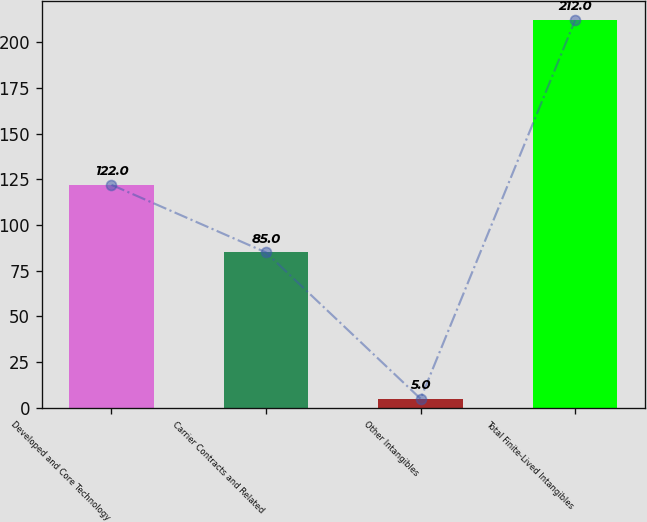Convert chart to OTSL. <chart><loc_0><loc_0><loc_500><loc_500><bar_chart><fcel>Developed and Core Technology<fcel>Carrier Contracts and Related<fcel>Other Intangibles<fcel>Total Finite-Lived Intangibles<nl><fcel>122<fcel>85<fcel>5<fcel>212<nl></chart> 